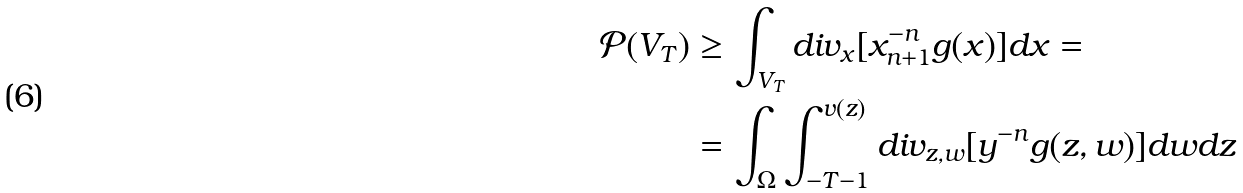Convert formula to latex. <formula><loc_0><loc_0><loc_500><loc_500>\mathcal { P } ( V _ { T } ) & \geq \int _ { V _ { T } } d i v _ { x } [ x _ { n + 1 } ^ { - n } g ( x ) ] d x = \\ & = \int _ { \Omega } \int _ { - T - 1 } ^ { v ( z ) } d i v _ { z , w } [ y ^ { - n } g ( z , w ) ] d w d z</formula> 